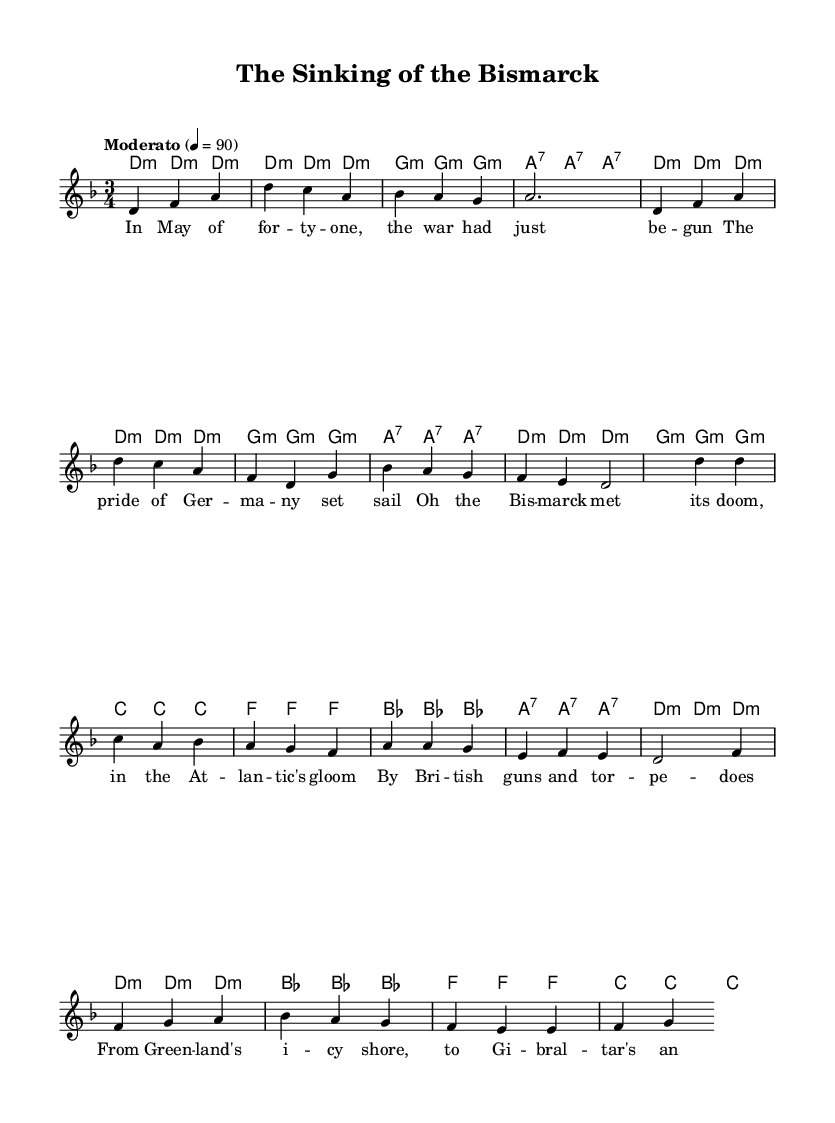What is the key signature of this music? The key signature at the beginning of the score indicates two flat notes (B and E), which means the piece is in D minor.
Answer: D minor What is the time signature of the piece? The time signature, shown at the beginning alongside the tempo, is 3/4, indicating three beats per measure.
Answer: 3/4 What is the tempo marking for the music? The tempo marking is indicated as "Moderato" with a metronome marking of 4=90, specifying a moderate pace at 90 beats per minute.
Answer: Moderato How many verses are present in the song? There is only one complete verse provided in the score, which is noted above the melody line. The other sections are the chorus and a bridge.
Answer: One Which naval battle is recounted in this ballad? The title of the ballad, "The Sinking of the Bismarck," indicates that the song recounts the naval battle involving the sinking of the German battleship Bismarck.
Answer: The Sinking of the Bismarck What is the overall structure of the song? The song has a structure that includes an intro, a verse, a chorus, and a bridge, commonly found in folk ballads to narrate a story.
Answer: Intro, Verse, Chorus, Bridge 